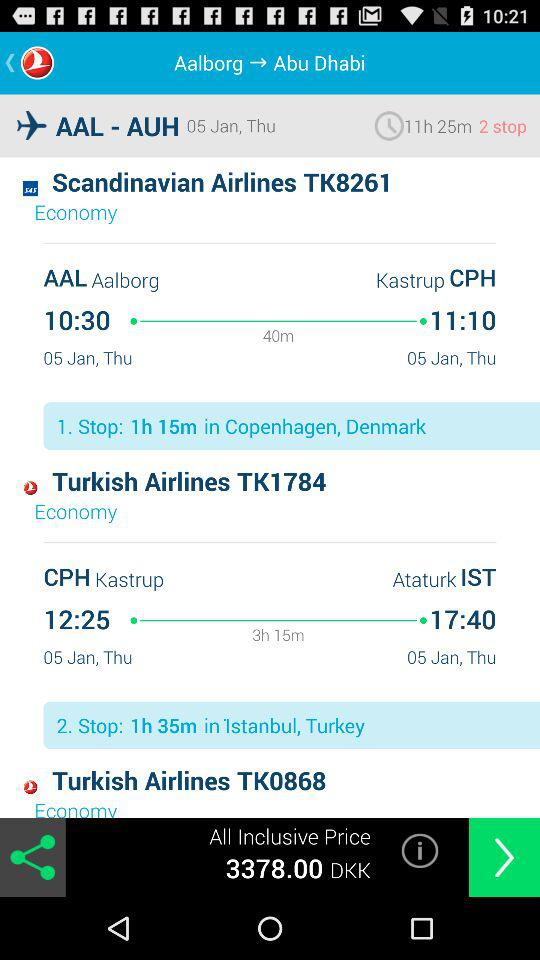What is the layover duration in Copenhagen, Denmark? The layover duration in Copenhagen, Denmark is 1 hour 15 minutes. 